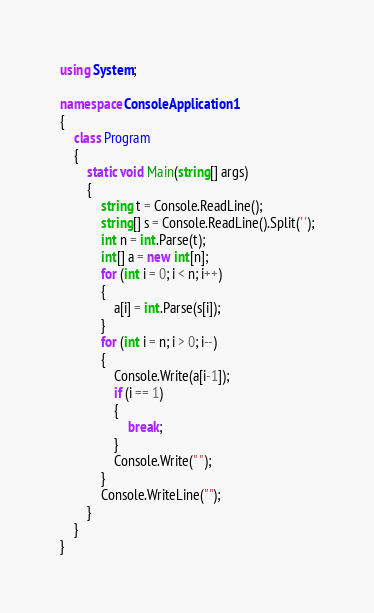Convert code to text. <code><loc_0><loc_0><loc_500><loc_500><_C#_>using System;

namespace ConsoleApplication1
{
    class Program
    {
        static void Main(string[] args)
        {
            string t = Console.ReadLine();
            string[] s = Console.ReadLine().Split(' ');
            int n = int.Parse(t);
            int[] a = new int[n];
            for (int i = 0; i < n; i++)
            {
                a[i] = int.Parse(s[i]);
            }
            for (int i = n; i > 0; i--)
            {
                Console.Write(a[i-1]);
                if (i == 1)
                {
                    break;
                }
                Console.Write(" ");
            }
            Console.WriteLine("");
        }
    }
}</code> 